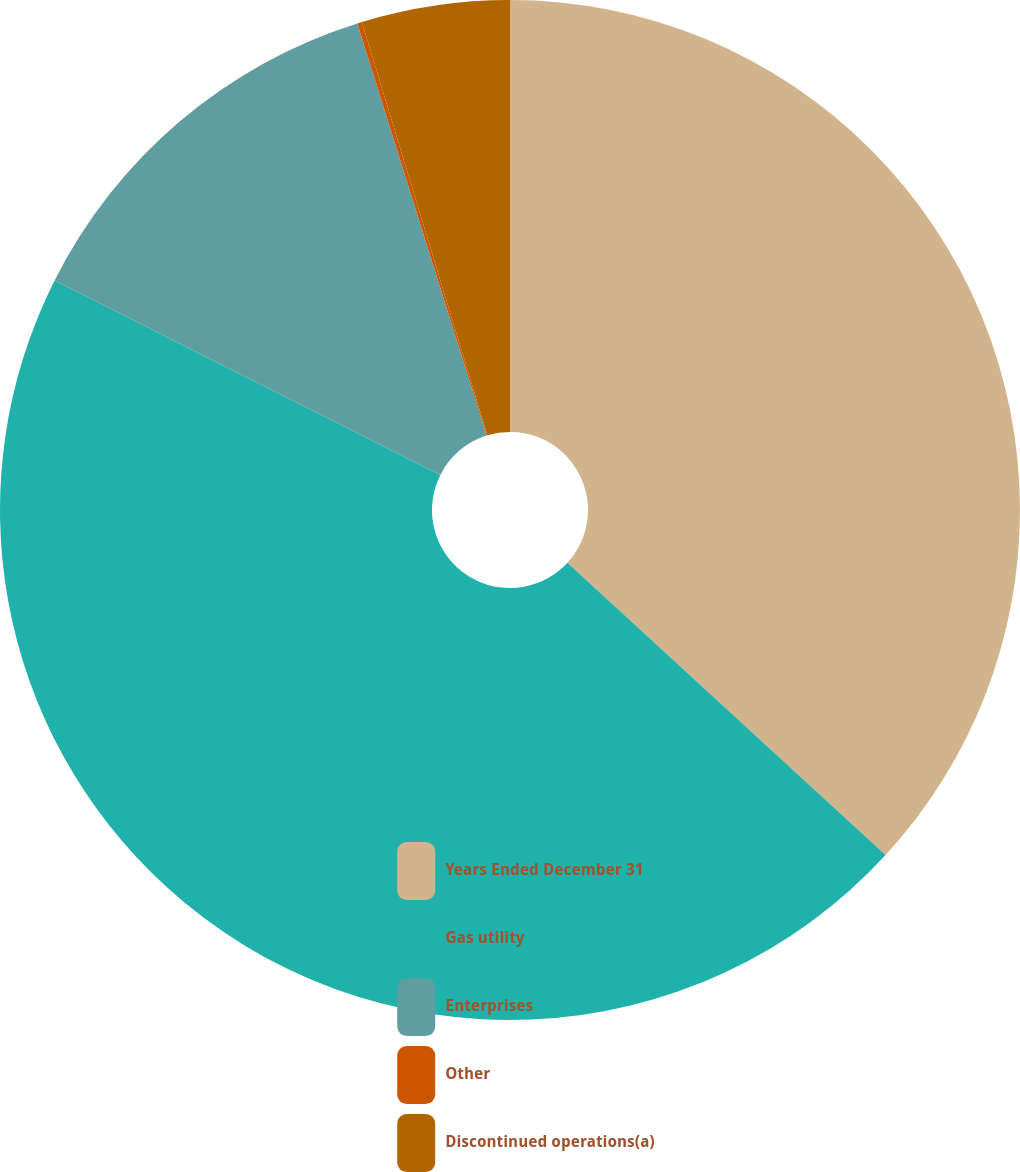Convert chart to OTSL. <chart><loc_0><loc_0><loc_500><loc_500><pie_chart><fcel>Years Ended December 31<fcel>Gas utility<fcel>Enterprises<fcel>Other<fcel>Discontinued operations(a)<nl><fcel>36.83%<fcel>45.61%<fcel>12.73%<fcel>0.15%<fcel>4.69%<nl></chart> 